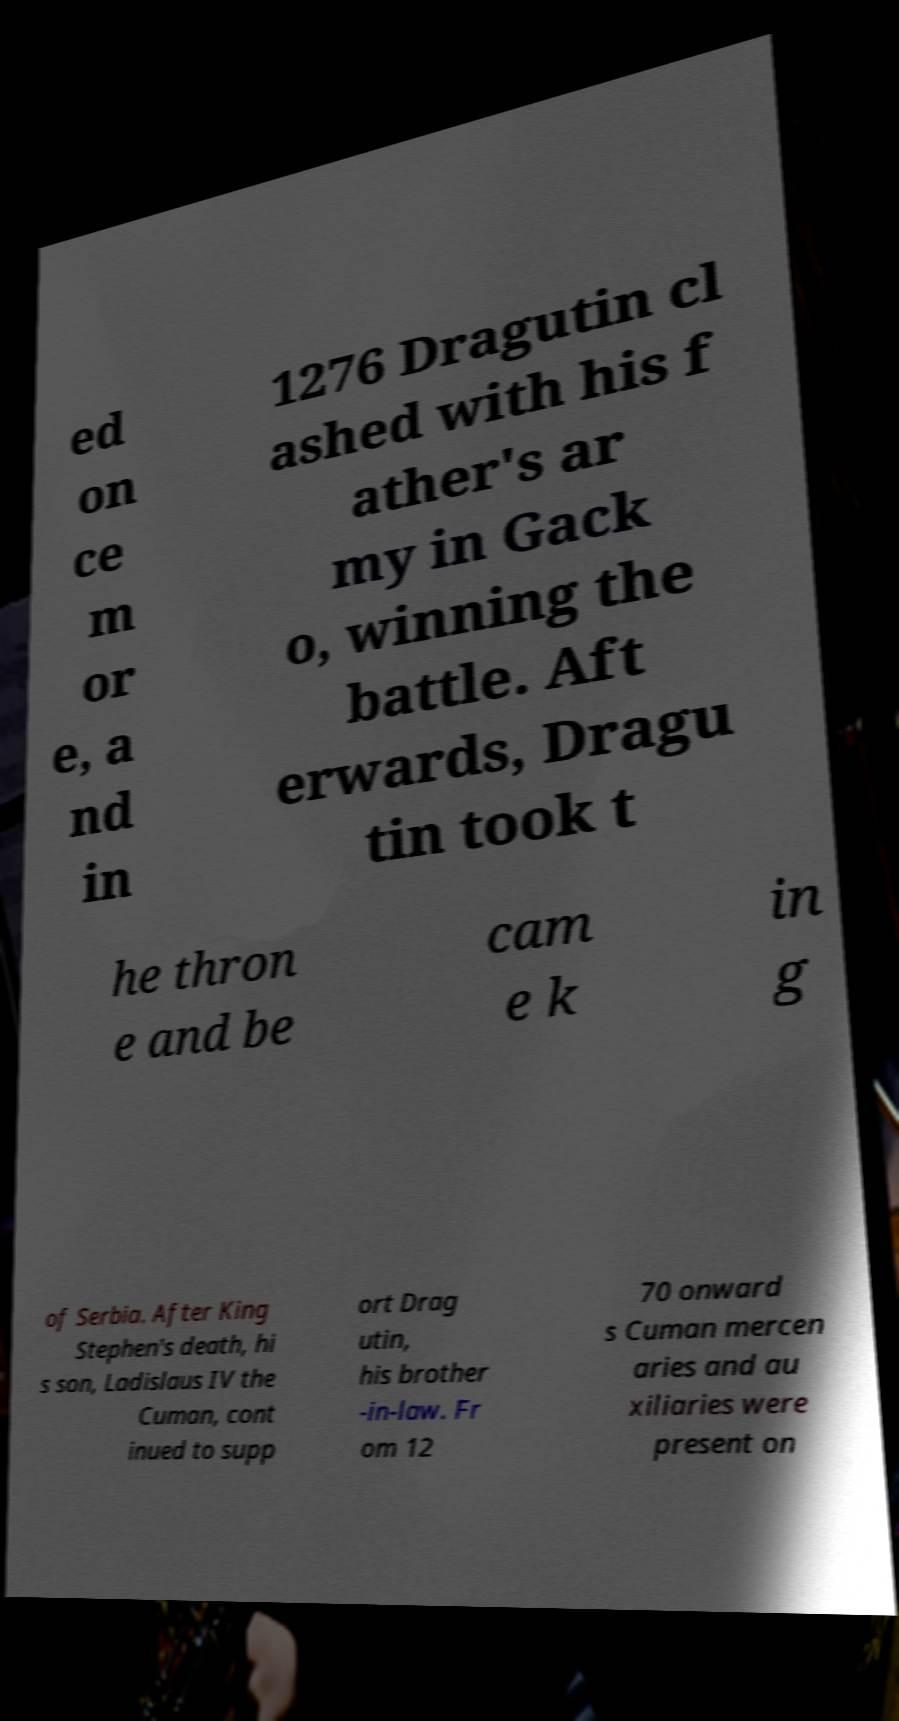Please read and relay the text visible in this image. What does it say? ed on ce m or e, a nd in 1276 Dragutin cl ashed with his f ather's ar my in Gack o, winning the battle. Aft erwards, Dragu tin took t he thron e and be cam e k in g of Serbia. After King Stephen's death, hi s son, Ladislaus IV the Cuman, cont inued to supp ort Drag utin, his brother -in-law. Fr om 12 70 onward s Cuman mercen aries and au xiliaries were present on 